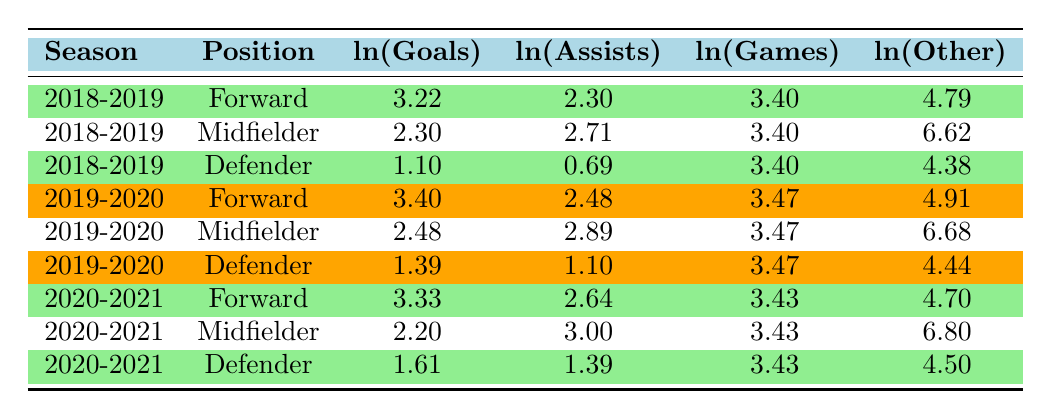What's the total number of goals scored by forwards in the 2019-2020 season? In the 2019-2020 season, the forward scored 30 goals. There is only one row for forwards in that season. Therefore, the total number of goals is 30.
Answer: 30 What is the difference in ln(Goals) between the highest scoring midfielder and the lowest scoring midfielder in 2018-2019? The highest scoring midfielder in 2018-2019 has ln(Goals) of 2.71 (10 goals) and the lowest has ln(Goals) of 2.30 (12 goals). The difference is 2.71 - 2.30 = 0.41.
Answer: 0.41 Did defenders score more goals in 2019-2020 compared to 2018-2019? In 2018-2019, defenders scored 3 goals (ln(Goals) = 1.10), and in 2019-2020, they scored 4 goals (ln(Goals) = 1.39). Since 4 is greater than 3, the answer is yes.
Answer: Yes What is the average number of assists from midfielders over the three seasons? The assists in each season are: 15 (2018-2019), 18 (2019-2020), and 20 (2020-2021). The total assists sum is 15 + 18 + 20 = 53. There are 3 seasons, so the average is 53 / 3 ≈ 17.67.
Answer: 17.67 Which position had the highest ln(Assists) in the 2020-2021 season? In 2020-2021, the ln(Assists) for midfielders is 3.00, for forwards is 2.64, and for defenders is 1.39. The highest ln(Assists) is for midfielders at 3.00.
Answer: Midfielder What is the total ratio of ln(Games) to ln(Goals) for forwards across all seasons? The ln(Games) for forwards are 3.40 + 3.47 + 3.43 = 10.30, and the ln(Goals) for forwards are 3.22 + 3.40 + 3.33 = 10.95. The ratio is 10.30 / 10.95 ≈ 0.94.
Answer: 0.94 